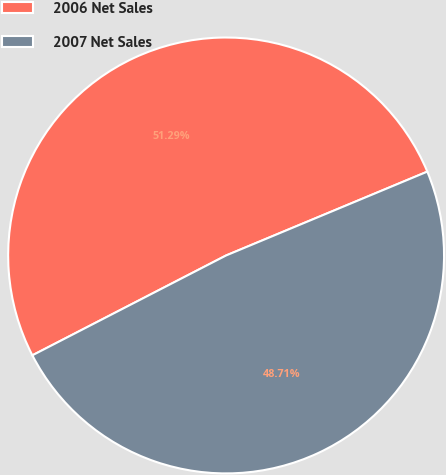Convert chart. <chart><loc_0><loc_0><loc_500><loc_500><pie_chart><fcel>2006 Net Sales<fcel>2007 Net Sales<nl><fcel>51.29%<fcel>48.71%<nl></chart> 